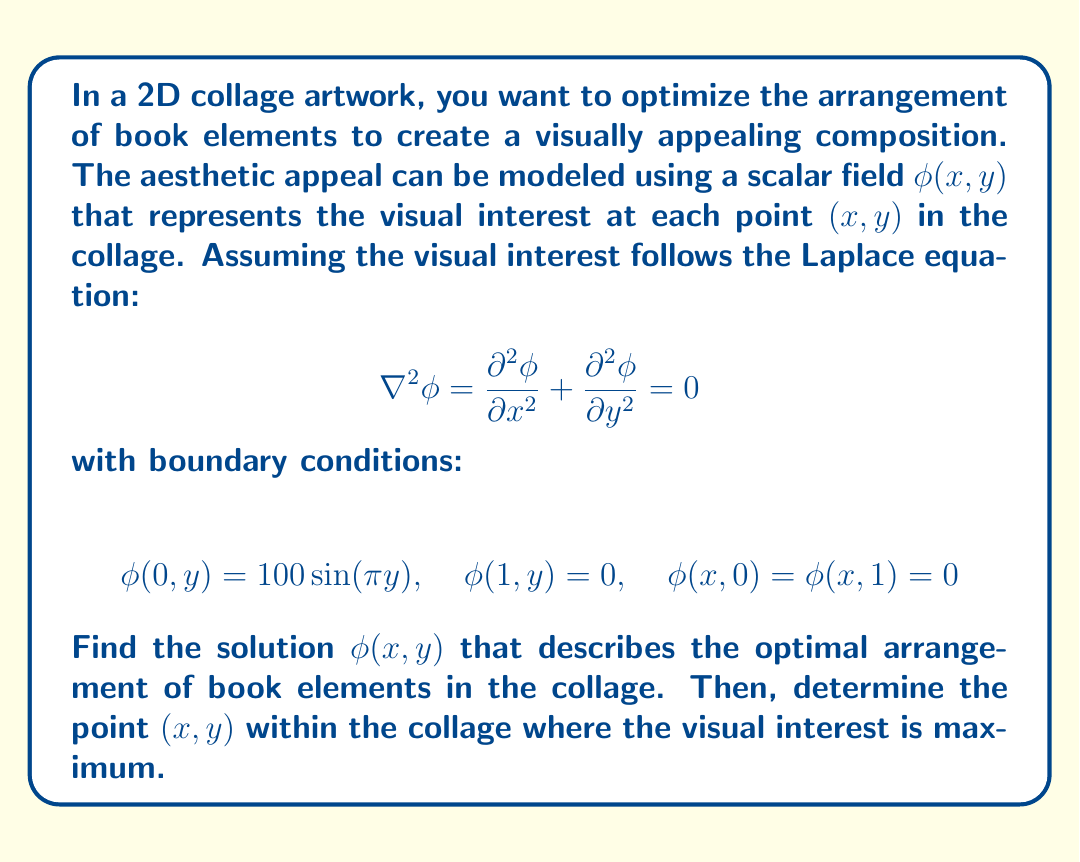Show me your answer to this math problem. To solve this problem, we'll use the method of separation of variables.

1) Assume the solution has the form $\phi(x,y) = X(x)Y(y)$.

2) Substituting into the Laplace equation:

   $$X''(x)Y(y) + X(x)Y''(y) = 0$$
   $$\frac{X''(x)}{X(x)} = -\frac{Y''(y)}{Y(y)} = -\lambda^2$$

3) This gives us two ODEs:
   $$X''(x) + \lambda^2X(x) = 0$$
   $$Y''(y) - \lambda^2Y(y) = 0$$

4) The general solutions are:
   $$X(x) = A\cos(\lambda x) + B\sin(\lambda x)$$
   $$Y(y) = Ce^{\lambda y} + De^{-\lambda y}$$

5) Applying the boundary conditions $\phi(x,0) = \phi(x,1) = 0$:
   $$Y(0) = Y(1) = 0 \implies \lambda = n\pi, n = 1,2,3,...$$

6) The general solution becomes:
   $$\phi(x,y) = \sum_{n=1}^{\infty} (A_n\cos(n\pi x) + B_n\sin(n\pi x))\sin(n\pi y)$$

7) Applying $\phi(1,y) = 0$:
   $$A_n\cos(n\pi) + B_n\sin(n\pi) = 0 \implies A_n = 0$$

8) The solution simplifies to:
   $$\phi(x,y) = \sum_{n=1}^{\infty} B_n\sin(n\pi x)\sin(n\pi y)$$

9) Applying $\phi(0,y) = 100\sin(\pi y)$:
   $$100\sin(\pi y) = \sum_{n=1}^{\infty} B_n\sin(0)\sin(n\pi y)$$

   This implies $B_1 = 100$ and $B_n = 0$ for $n > 1$.

10) Therefore, the final solution is:
    $$\phi(x,y) = 100\sin(\pi x)\sin(\pi y)$$

11) To find the maximum, we calculate partial derivatives:
    $$\frac{\partial\phi}{\partial x} = 100\pi\cos(\pi x)\sin(\pi y)$$
    $$\frac{\partial\phi}{\partial y} = 100\pi\sin(\pi x)\cos(\pi y)$$

12) Setting both to zero:
    $$\cos(\pi x)\sin(\pi y) = 0 \quad \text{and} \quad \sin(\pi x)\cos(\pi y) = 0$$

    This occurs when $x = \frac{1}{2}$ and $y = \frac{1}{2}$.

13) Confirming this is a maximum:
    $$\frac{\partial^2\phi}{\partial x^2} = -100\pi^2\sin(\pi x)\sin(\pi y)$$
    $$\frac{\partial^2\phi}{\partial y^2} = -100\pi^2\sin(\pi x)\sin(\pi y)$$

    Both are negative at $(\frac{1}{2}, \frac{1}{2})$, confirming a maximum.
Answer: The solution describing the optimal arrangement of book elements in the collage is:

$$\phi(x,y) = 100\sin(\pi x)\sin(\pi y)$$

The point of maximum visual interest is $(\frac{1}{2}, \frac{1}{2})$, which is the center of the collage. 